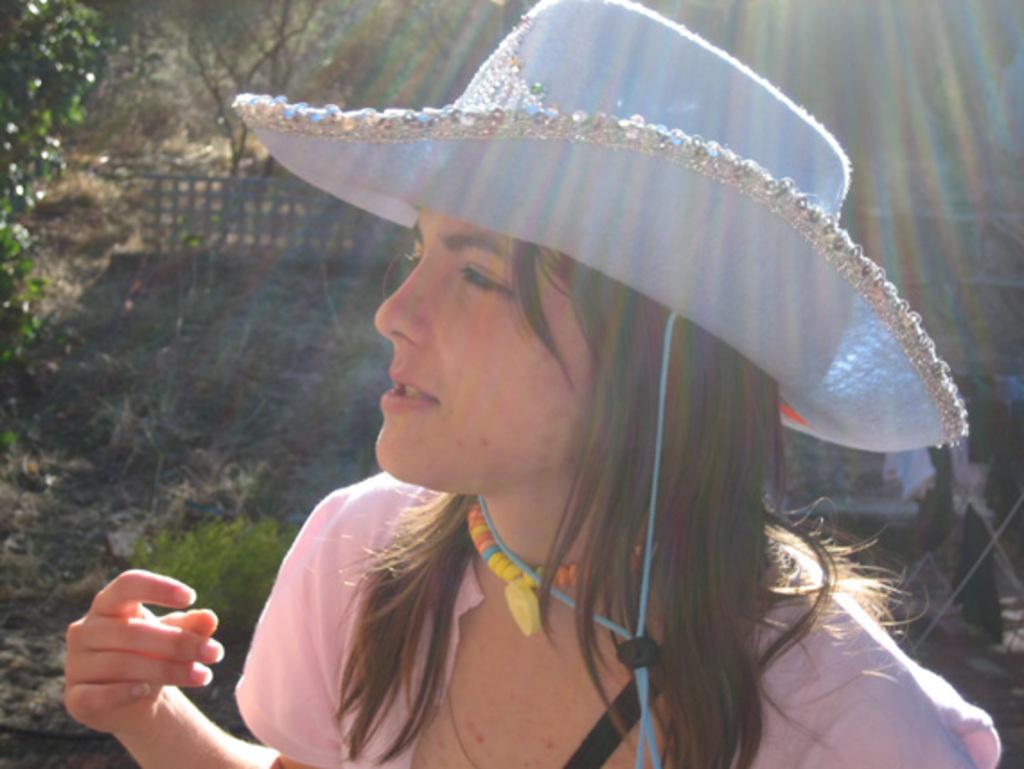Please provide a concise description of this image. In this image in front there is a person wearing a hat. In the background of the image there is a metal fence. There are trees. 